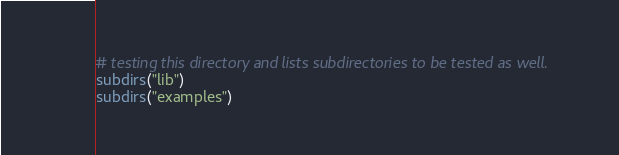Convert code to text. <code><loc_0><loc_0><loc_500><loc_500><_CMake_># testing this directory and lists subdirectories to be tested as well.
subdirs("lib")
subdirs("examples")
</code> 